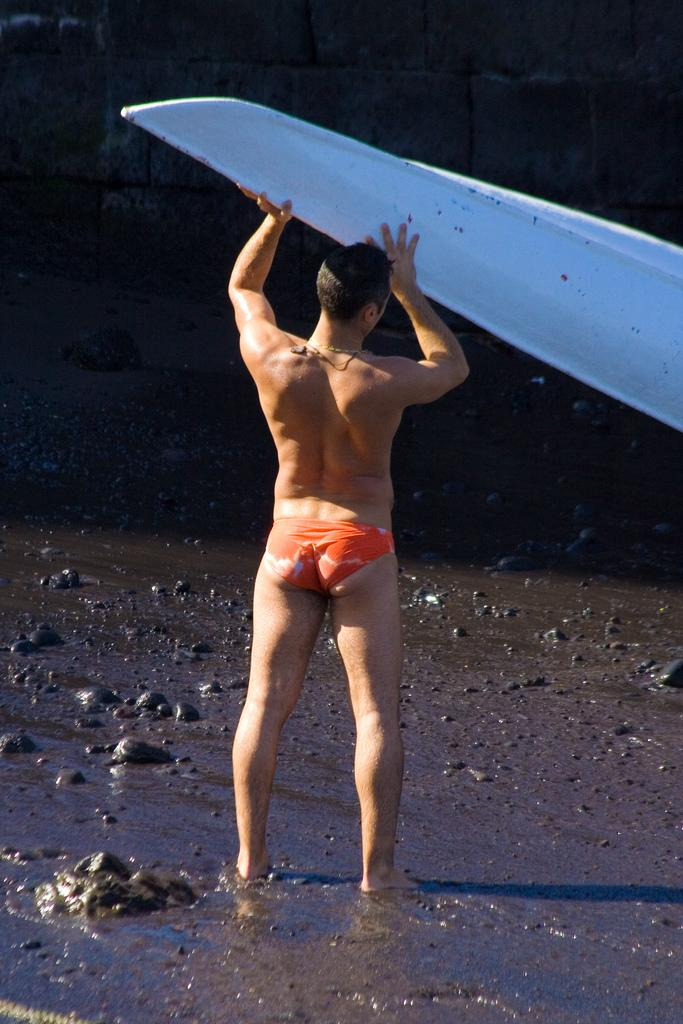What is the main subject of the image? The main subject of the image is a man standing. Can you describe the background of the image? There is a wall in the background of the image. What type of health advice is the man giving in the image? There is no indication in the image that the man is giving any health advice. What is the manager's role in the image? There is no manager present in the image. 